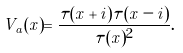Convert formula to latex. <formula><loc_0><loc_0><loc_500><loc_500>V _ { a } ( x ) = \frac { \tau ( x + i ) \tau ( x - i ) } { \tau ( x ) ^ { 2 } } .</formula> 